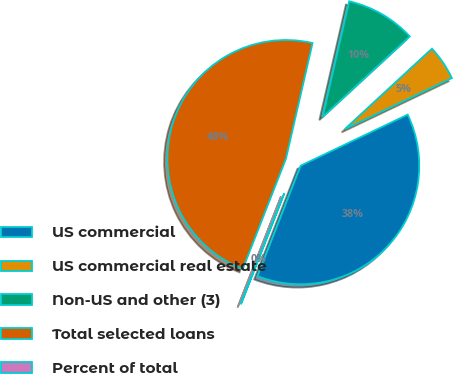<chart> <loc_0><loc_0><loc_500><loc_500><pie_chart><fcel>US commercial<fcel>US commercial real estate<fcel>Non-US and other (3)<fcel>Total selected loans<fcel>Percent of total<nl><fcel>38.01%<fcel>4.78%<fcel>9.54%<fcel>47.66%<fcel>0.01%<nl></chart> 